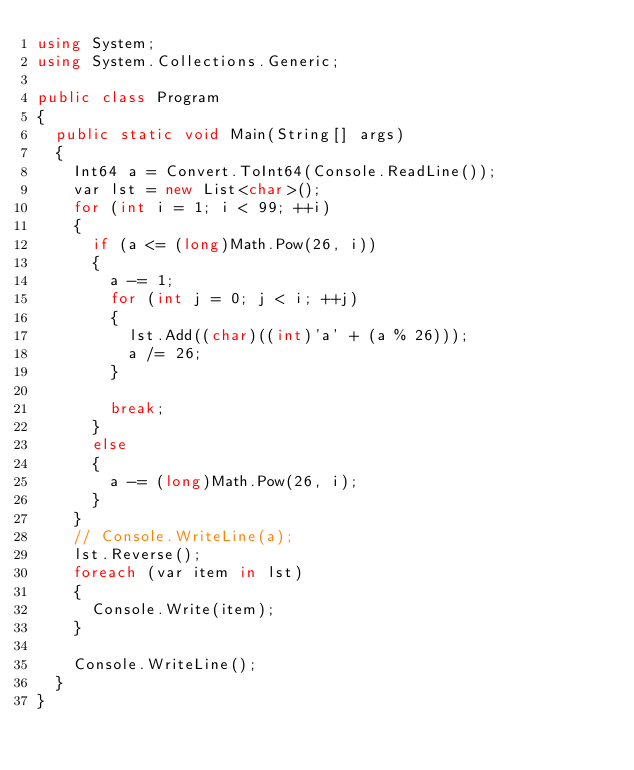<code> <loc_0><loc_0><loc_500><loc_500><_C#_>using System;
using System.Collections.Generic;

public class Program
{
	public static void Main(String[] args)
	{
		Int64 a = Convert.ToInt64(Console.ReadLine());
		var lst = new List<char>();
		for (int i = 1; i < 99; ++i)
		{
			if (a <= (long)Math.Pow(26, i))
			{
				a -= 1;
				for (int j = 0; j < i; ++j)
				{
					lst.Add((char)((int)'a' + (a % 26)));
					a /= 26;
				}

				break;
			}
			else
			{
				a -= (long)Math.Pow(26, i);
			}
		}
		// Console.WriteLine(a);
		lst.Reverse();
		foreach (var item in lst)
		{
			Console.Write(item);
		}

		Console.WriteLine();
	}
}</code> 